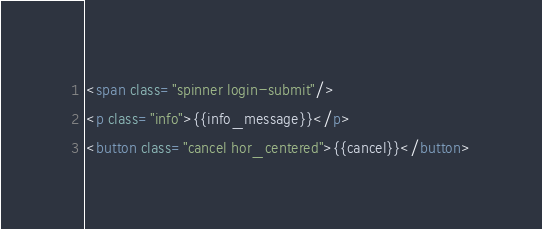Convert code to text. <code><loc_0><loc_0><loc_500><loc_500><_HTML_><span class="spinner login-submit"/>
<p class="info">{{info_message}}</p>
<button class="cancel hor_centered">{{cancel}}</button>
</code> 